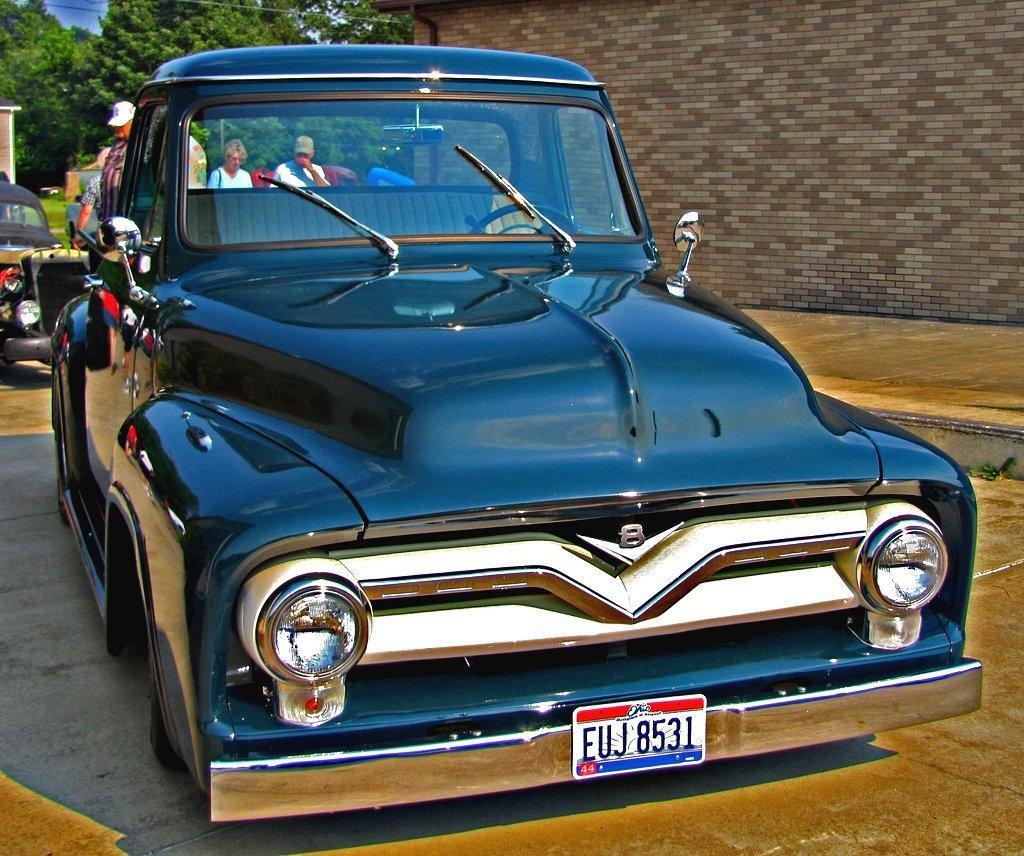How would you summarize this image in a sentence or two? In this picture we can see a few vehicles on the path. There are some people and few trees are seen at the back. A wall is visible on the right side. 